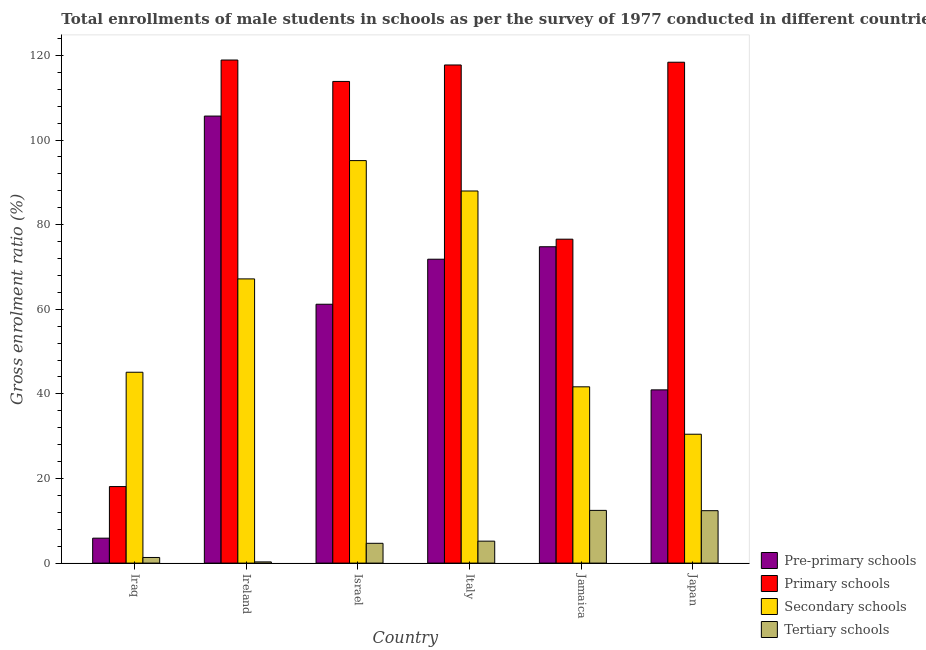How many different coloured bars are there?
Provide a succinct answer. 4. How many groups of bars are there?
Provide a short and direct response. 6. Are the number of bars per tick equal to the number of legend labels?
Ensure brevity in your answer.  Yes. Are the number of bars on each tick of the X-axis equal?
Your answer should be very brief. Yes. In how many cases, is the number of bars for a given country not equal to the number of legend labels?
Keep it short and to the point. 0. What is the gross enrolment ratio(male) in primary schools in Italy?
Your response must be concise. 117.75. Across all countries, what is the maximum gross enrolment ratio(male) in primary schools?
Ensure brevity in your answer.  118.92. Across all countries, what is the minimum gross enrolment ratio(male) in secondary schools?
Your response must be concise. 30.46. In which country was the gross enrolment ratio(male) in pre-primary schools maximum?
Give a very brief answer. Ireland. In which country was the gross enrolment ratio(male) in secondary schools minimum?
Keep it short and to the point. Japan. What is the total gross enrolment ratio(male) in secondary schools in the graph?
Your answer should be very brief. 367.54. What is the difference between the gross enrolment ratio(male) in primary schools in Israel and that in Italy?
Keep it short and to the point. -3.89. What is the difference between the gross enrolment ratio(male) in tertiary schools in Japan and the gross enrolment ratio(male) in primary schools in Iraq?
Ensure brevity in your answer.  -5.7. What is the average gross enrolment ratio(male) in secondary schools per country?
Offer a very short reply. 61.26. What is the difference between the gross enrolment ratio(male) in pre-primary schools and gross enrolment ratio(male) in primary schools in Iraq?
Your answer should be compact. -12.2. In how many countries, is the gross enrolment ratio(male) in secondary schools greater than 100 %?
Your answer should be compact. 0. What is the ratio of the gross enrolment ratio(male) in tertiary schools in Israel to that in Italy?
Give a very brief answer. 0.9. Is the gross enrolment ratio(male) in primary schools in Iraq less than that in Italy?
Ensure brevity in your answer.  Yes. What is the difference between the highest and the second highest gross enrolment ratio(male) in secondary schools?
Give a very brief answer. 7.18. What is the difference between the highest and the lowest gross enrolment ratio(male) in secondary schools?
Provide a succinct answer. 64.68. What does the 3rd bar from the left in Ireland represents?
Keep it short and to the point. Secondary schools. What does the 4th bar from the right in Italy represents?
Make the answer very short. Pre-primary schools. Is it the case that in every country, the sum of the gross enrolment ratio(male) in pre-primary schools and gross enrolment ratio(male) in primary schools is greater than the gross enrolment ratio(male) in secondary schools?
Provide a succinct answer. No. Are the values on the major ticks of Y-axis written in scientific E-notation?
Give a very brief answer. No. Does the graph contain any zero values?
Offer a terse response. No. Does the graph contain grids?
Your answer should be compact. No. How are the legend labels stacked?
Offer a terse response. Vertical. What is the title of the graph?
Your response must be concise. Total enrollments of male students in schools as per the survey of 1977 conducted in different countries. What is the label or title of the X-axis?
Provide a succinct answer. Country. What is the label or title of the Y-axis?
Offer a terse response. Gross enrolment ratio (%). What is the Gross enrolment ratio (%) in Pre-primary schools in Iraq?
Your response must be concise. 5.89. What is the Gross enrolment ratio (%) in Primary schools in Iraq?
Provide a short and direct response. 18.09. What is the Gross enrolment ratio (%) of Secondary schools in Iraq?
Make the answer very short. 45.11. What is the Gross enrolment ratio (%) of Tertiary schools in Iraq?
Your answer should be very brief. 1.33. What is the Gross enrolment ratio (%) of Pre-primary schools in Ireland?
Your answer should be compact. 105.67. What is the Gross enrolment ratio (%) of Primary schools in Ireland?
Ensure brevity in your answer.  118.92. What is the Gross enrolment ratio (%) of Secondary schools in Ireland?
Your response must be concise. 67.18. What is the Gross enrolment ratio (%) in Tertiary schools in Ireland?
Ensure brevity in your answer.  0.28. What is the Gross enrolment ratio (%) in Pre-primary schools in Israel?
Make the answer very short. 61.19. What is the Gross enrolment ratio (%) of Primary schools in Israel?
Your response must be concise. 113.86. What is the Gross enrolment ratio (%) of Secondary schools in Israel?
Provide a short and direct response. 95.14. What is the Gross enrolment ratio (%) in Tertiary schools in Israel?
Offer a terse response. 4.68. What is the Gross enrolment ratio (%) in Pre-primary schools in Italy?
Keep it short and to the point. 71.83. What is the Gross enrolment ratio (%) of Primary schools in Italy?
Make the answer very short. 117.75. What is the Gross enrolment ratio (%) in Secondary schools in Italy?
Keep it short and to the point. 87.96. What is the Gross enrolment ratio (%) in Tertiary schools in Italy?
Make the answer very short. 5.19. What is the Gross enrolment ratio (%) of Pre-primary schools in Jamaica?
Your response must be concise. 74.78. What is the Gross enrolment ratio (%) of Primary schools in Jamaica?
Make the answer very short. 76.57. What is the Gross enrolment ratio (%) of Secondary schools in Jamaica?
Give a very brief answer. 41.67. What is the Gross enrolment ratio (%) of Tertiary schools in Jamaica?
Your answer should be very brief. 12.46. What is the Gross enrolment ratio (%) in Pre-primary schools in Japan?
Your answer should be compact. 40.95. What is the Gross enrolment ratio (%) in Primary schools in Japan?
Keep it short and to the point. 118.4. What is the Gross enrolment ratio (%) in Secondary schools in Japan?
Provide a short and direct response. 30.46. What is the Gross enrolment ratio (%) in Tertiary schools in Japan?
Provide a succinct answer. 12.39. Across all countries, what is the maximum Gross enrolment ratio (%) of Pre-primary schools?
Your response must be concise. 105.67. Across all countries, what is the maximum Gross enrolment ratio (%) in Primary schools?
Provide a succinct answer. 118.92. Across all countries, what is the maximum Gross enrolment ratio (%) of Secondary schools?
Offer a terse response. 95.14. Across all countries, what is the maximum Gross enrolment ratio (%) in Tertiary schools?
Make the answer very short. 12.46. Across all countries, what is the minimum Gross enrolment ratio (%) in Pre-primary schools?
Your answer should be very brief. 5.89. Across all countries, what is the minimum Gross enrolment ratio (%) of Primary schools?
Keep it short and to the point. 18.09. Across all countries, what is the minimum Gross enrolment ratio (%) of Secondary schools?
Give a very brief answer. 30.46. Across all countries, what is the minimum Gross enrolment ratio (%) of Tertiary schools?
Offer a terse response. 0.28. What is the total Gross enrolment ratio (%) in Pre-primary schools in the graph?
Ensure brevity in your answer.  360.31. What is the total Gross enrolment ratio (%) in Primary schools in the graph?
Offer a very short reply. 563.58. What is the total Gross enrolment ratio (%) in Secondary schools in the graph?
Provide a succinct answer. 367.54. What is the total Gross enrolment ratio (%) in Tertiary schools in the graph?
Give a very brief answer. 36.33. What is the difference between the Gross enrolment ratio (%) in Pre-primary schools in Iraq and that in Ireland?
Your response must be concise. -99.78. What is the difference between the Gross enrolment ratio (%) of Primary schools in Iraq and that in Ireland?
Your response must be concise. -100.83. What is the difference between the Gross enrolment ratio (%) in Secondary schools in Iraq and that in Ireland?
Offer a very short reply. -22.07. What is the difference between the Gross enrolment ratio (%) of Tertiary schools in Iraq and that in Ireland?
Give a very brief answer. 1.05. What is the difference between the Gross enrolment ratio (%) in Pre-primary schools in Iraq and that in Israel?
Make the answer very short. -55.29. What is the difference between the Gross enrolment ratio (%) in Primary schools in Iraq and that in Israel?
Ensure brevity in your answer.  -95.77. What is the difference between the Gross enrolment ratio (%) in Secondary schools in Iraq and that in Israel?
Provide a succinct answer. -50.03. What is the difference between the Gross enrolment ratio (%) in Tertiary schools in Iraq and that in Israel?
Your answer should be very brief. -3.35. What is the difference between the Gross enrolment ratio (%) of Pre-primary schools in Iraq and that in Italy?
Make the answer very short. -65.94. What is the difference between the Gross enrolment ratio (%) of Primary schools in Iraq and that in Italy?
Your answer should be very brief. -99.66. What is the difference between the Gross enrolment ratio (%) of Secondary schools in Iraq and that in Italy?
Make the answer very short. -42.85. What is the difference between the Gross enrolment ratio (%) in Tertiary schools in Iraq and that in Italy?
Offer a terse response. -3.86. What is the difference between the Gross enrolment ratio (%) of Pre-primary schools in Iraq and that in Jamaica?
Provide a short and direct response. -68.89. What is the difference between the Gross enrolment ratio (%) of Primary schools in Iraq and that in Jamaica?
Your response must be concise. -58.48. What is the difference between the Gross enrolment ratio (%) of Secondary schools in Iraq and that in Jamaica?
Your answer should be very brief. 3.44. What is the difference between the Gross enrolment ratio (%) in Tertiary schools in Iraq and that in Jamaica?
Your response must be concise. -11.13. What is the difference between the Gross enrolment ratio (%) in Pre-primary schools in Iraq and that in Japan?
Provide a short and direct response. -35.05. What is the difference between the Gross enrolment ratio (%) of Primary schools in Iraq and that in Japan?
Keep it short and to the point. -100.31. What is the difference between the Gross enrolment ratio (%) in Secondary schools in Iraq and that in Japan?
Offer a terse response. 14.65. What is the difference between the Gross enrolment ratio (%) of Tertiary schools in Iraq and that in Japan?
Keep it short and to the point. -11.06. What is the difference between the Gross enrolment ratio (%) in Pre-primary schools in Ireland and that in Israel?
Your answer should be compact. 44.48. What is the difference between the Gross enrolment ratio (%) in Primary schools in Ireland and that in Israel?
Your answer should be very brief. 5.06. What is the difference between the Gross enrolment ratio (%) of Secondary schools in Ireland and that in Israel?
Offer a terse response. -27.96. What is the difference between the Gross enrolment ratio (%) in Tertiary schools in Ireland and that in Israel?
Keep it short and to the point. -4.39. What is the difference between the Gross enrolment ratio (%) in Pre-primary schools in Ireland and that in Italy?
Your answer should be very brief. 33.84. What is the difference between the Gross enrolment ratio (%) in Primary schools in Ireland and that in Italy?
Your response must be concise. 1.17. What is the difference between the Gross enrolment ratio (%) in Secondary schools in Ireland and that in Italy?
Your answer should be very brief. -20.78. What is the difference between the Gross enrolment ratio (%) in Tertiary schools in Ireland and that in Italy?
Offer a terse response. -4.9. What is the difference between the Gross enrolment ratio (%) of Pre-primary schools in Ireland and that in Jamaica?
Offer a terse response. 30.89. What is the difference between the Gross enrolment ratio (%) in Primary schools in Ireland and that in Jamaica?
Provide a short and direct response. 42.35. What is the difference between the Gross enrolment ratio (%) in Secondary schools in Ireland and that in Jamaica?
Your response must be concise. 25.51. What is the difference between the Gross enrolment ratio (%) in Tertiary schools in Ireland and that in Jamaica?
Offer a terse response. -12.18. What is the difference between the Gross enrolment ratio (%) of Pre-primary schools in Ireland and that in Japan?
Offer a terse response. 64.72. What is the difference between the Gross enrolment ratio (%) in Primary schools in Ireland and that in Japan?
Ensure brevity in your answer.  0.52. What is the difference between the Gross enrolment ratio (%) of Secondary schools in Ireland and that in Japan?
Give a very brief answer. 36.71. What is the difference between the Gross enrolment ratio (%) of Tertiary schools in Ireland and that in Japan?
Your response must be concise. -12.11. What is the difference between the Gross enrolment ratio (%) in Pre-primary schools in Israel and that in Italy?
Keep it short and to the point. -10.65. What is the difference between the Gross enrolment ratio (%) in Primary schools in Israel and that in Italy?
Offer a very short reply. -3.89. What is the difference between the Gross enrolment ratio (%) in Secondary schools in Israel and that in Italy?
Offer a terse response. 7.18. What is the difference between the Gross enrolment ratio (%) in Tertiary schools in Israel and that in Italy?
Provide a succinct answer. -0.51. What is the difference between the Gross enrolment ratio (%) of Pre-primary schools in Israel and that in Jamaica?
Offer a very short reply. -13.59. What is the difference between the Gross enrolment ratio (%) in Primary schools in Israel and that in Jamaica?
Keep it short and to the point. 37.29. What is the difference between the Gross enrolment ratio (%) in Secondary schools in Israel and that in Jamaica?
Offer a terse response. 53.47. What is the difference between the Gross enrolment ratio (%) of Tertiary schools in Israel and that in Jamaica?
Offer a terse response. -7.78. What is the difference between the Gross enrolment ratio (%) in Pre-primary schools in Israel and that in Japan?
Give a very brief answer. 20.24. What is the difference between the Gross enrolment ratio (%) in Primary schools in Israel and that in Japan?
Your answer should be compact. -4.54. What is the difference between the Gross enrolment ratio (%) in Secondary schools in Israel and that in Japan?
Ensure brevity in your answer.  64.68. What is the difference between the Gross enrolment ratio (%) of Tertiary schools in Israel and that in Japan?
Provide a short and direct response. -7.71. What is the difference between the Gross enrolment ratio (%) of Pre-primary schools in Italy and that in Jamaica?
Your answer should be compact. -2.95. What is the difference between the Gross enrolment ratio (%) of Primary schools in Italy and that in Jamaica?
Your answer should be very brief. 41.18. What is the difference between the Gross enrolment ratio (%) in Secondary schools in Italy and that in Jamaica?
Offer a terse response. 46.29. What is the difference between the Gross enrolment ratio (%) in Tertiary schools in Italy and that in Jamaica?
Your answer should be very brief. -7.27. What is the difference between the Gross enrolment ratio (%) of Pre-primary schools in Italy and that in Japan?
Your answer should be very brief. 30.89. What is the difference between the Gross enrolment ratio (%) in Primary schools in Italy and that in Japan?
Your answer should be very brief. -0.65. What is the difference between the Gross enrolment ratio (%) of Secondary schools in Italy and that in Japan?
Keep it short and to the point. 57.5. What is the difference between the Gross enrolment ratio (%) of Tertiary schools in Italy and that in Japan?
Offer a very short reply. -7.2. What is the difference between the Gross enrolment ratio (%) of Pre-primary schools in Jamaica and that in Japan?
Offer a very short reply. 33.83. What is the difference between the Gross enrolment ratio (%) of Primary schools in Jamaica and that in Japan?
Your answer should be very brief. -41.83. What is the difference between the Gross enrolment ratio (%) in Secondary schools in Jamaica and that in Japan?
Ensure brevity in your answer.  11.21. What is the difference between the Gross enrolment ratio (%) in Tertiary schools in Jamaica and that in Japan?
Your answer should be compact. 0.07. What is the difference between the Gross enrolment ratio (%) of Pre-primary schools in Iraq and the Gross enrolment ratio (%) of Primary schools in Ireland?
Give a very brief answer. -113.02. What is the difference between the Gross enrolment ratio (%) in Pre-primary schools in Iraq and the Gross enrolment ratio (%) in Secondary schools in Ireland?
Your response must be concise. -61.29. What is the difference between the Gross enrolment ratio (%) in Pre-primary schools in Iraq and the Gross enrolment ratio (%) in Tertiary schools in Ireland?
Offer a very short reply. 5.61. What is the difference between the Gross enrolment ratio (%) in Primary schools in Iraq and the Gross enrolment ratio (%) in Secondary schools in Ireland?
Ensure brevity in your answer.  -49.09. What is the difference between the Gross enrolment ratio (%) in Primary schools in Iraq and the Gross enrolment ratio (%) in Tertiary schools in Ireland?
Offer a very short reply. 17.81. What is the difference between the Gross enrolment ratio (%) in Secondary schools in Iraq and the Gross enrolment ratio (%) in Tertiary schools in Ireland?
Provide a succinct answer. 44.83. What is the difference between the Gross enrolment ratio (%) of Pre-primary schools in Iraq and the Gross enrolment ratio (%) of Primary schools in Israel?
Your answer should be very brief. -107.96. What is the difference between the Gross enrolment ratio (%) in Pre-primary schools in Iraq and the Gross enrolment ratio (%) in Secondary schools in Israel?
Keep it short and to the point. -89.25. What is the difference between the Gross enrolment ratio (%) of Pre-primary schools in Iraq and the Gross enrolment ratio (%) of Tertiary schools in Israel?
Make the answer very short. 1.22. What is the difference between the Gross enrolment ratio (%) of Primary schools in Iraq and the Gross enrolment ratio (%) of Secondary schools in Israel?
Offer a very short reply. -77.05. What is the difference between the Gross enrolment ratio (%) in Primary schools in Iraq and the Gross enrolment ratio (%) in Tertiary schools in Israel?
Ensure brevity in your answer.  13.41. What is the difference between the Gross enrolment ratio (%) of Secondary schools in Iraq and the Gross enrolment ratio (%) of Tertiary schools in Israel?
Your answer should be very brief. 40.44. What is the difference between the Gross enrolment ratio (%) in Pre-primary schools in Iraq and the Gross enrolment ratio (%) in Primary schools in Italy?
Give a very brief answer. -111.85. What is the difference between the Gross enrolment ratio (%) of Pre-primary schools in Iraq and the Gross enrolment ratio (%) of Secondary schools in Italy?
Your response must be concise. -82.07. What is the difference between the Gross enrolment ratio (%) in Pre-primary schools in Iraq and the Gross enrolment ratio (%) in Tertiary schools in Italy?
Offer a terse response. 0.71. What is the difference between the Gross enrolment ratio (%) of Primary schools in Iraq and the Gross enrolment ratio (%) of Secondary schools in Italy?
Make the answer very short. -69.87. What is the difference between the Gross enrolment ratio (%) of Primary schools in Iraq and the Gross enrolment ratio (%) of Tertiary schools in Italy?
Provide a short and direct response. 12.9. What is the difference between the Gross enrolment ratio (%) of Secondary schools in Iraq and the Gross enrolment ratio (%) of Tertiary schools in Italy?
Your response must be concise. 39.93. What is the difference between the Gross enrolment ratio (%) of Pre-primary schools in Iraq and the Gross enrolment ratio (%) of Primary schools in Jamaica?
Your response must be concise. -70.67. What is the difference between the Gross enrolment ratio (%) of Pre-primary schools in Iraq and the Gross enrolment ratio (%) of Secondary schools in Jamaica?
Your response must be concise. -35.78. What is the difference between the Gross enrolment ratio (%) in Pre-primary schools in Iraq and the Gross enrolment ratio (%) in Tertiary schools in Jamaica?
Ensure brevity in your answer.  -6.57. What is the difference between the Gross enrolment ratio (%) in Primary schools in Iraq and the Gross enrolment ratio (%) in Secondary schools in Jamaica?
Provide a short and direct response. -23.58. What is the difference between the Gross enrolment ratio (%) of Primary schools in Iraq and the Gross enrolment ratio (%) of Tertiary schools in Jamaica?
Ensure brevity in your answer.  5.63. What is the difference between the Gross enrolment ratio (%) of Secondary schools in Iraq and the Gross enrolment ratio (%) of Tertiary schools in Jamaica?
Give a very brief answer. 32.65. What is the difference between the Gross enrolment ratio (%) of Pre-primary schools in Iraq and the Gross enrolment ratio (%) of Primary schools in Japan?
Provide a succinct answer. -112.51. What is the difference between the Gross enrolment ratio (%) of Pre-primary schools in Iraq and the Gross enrolment ratio (%) of Secondary schools in Japan?
Ensure brevity in your answer.  -24.57. What is the difference between the Gross enrolment ratio (%) of Pre-primary schools in Iraq and the Gross enrolment ratio (%) of Tertiary schools in Japan?
Your response must be concise. -6.5. What is the difference between the Gross enrolment ratio (%) of Primary schools in Iraq and the Gross enrolment ratio (%) of Secondary schools in Japan?
Provide a short and direct response. -12.37. What is the difference between the Gross enrolment ratio (%) in Secondary schools in Iraq and the Gross enrolment ratio (%) in Tertiary schools in Japan?
Provide a succinct answer. 32.72. What is the difference between the Gross enrolment ratio (%) in Pre-primary schools in Ireland and the Gross enrolment ratio (%) in Primary schools in Israel?
Offer a terse response. -8.19. What is the difference between the Gross enrolment ratio (%) in Pre-primary schools in Ireland and the Gross enrolment ratio (%) in Secondary schools in Israel?
Give a very brief answer. 10.53. What is the difference between the Gross enrolment ratio (%) in Pre-primary schools in Ireland and the Gross enrolment ratio (%) in Tertiary schools in Israel?
Ensure brevity in your answer.  100.99. What is the difference between the Gross enrolment ratio (%) of Primary schools in Ireland and the Gross enrolment ratio (%) of Secondary schools in Israel?
Give a very brief answer. 23.77. What is the difference between the Gross enrolment ratio (%) of Primary schools in Ireland and the Gross enrolment ratio (%) of Tertiary schools in Israel?
Give a very brief answer. 114.24. What is the difference between the Gross enrolment ratio (%) in Secondary schools in Ireland and the Gross enrolment ratio (%) in Tertiary schools in Israel?
Offer a very short reply. 62.5. What is the difference between the Gross enrolment ratio (%) of Pre-primary schools in Ireland and the Gross enrolment ratio (%) of Primary schools in Italy?
Your answer should be compact. -12.08. What is the difference between the Gross enrolment ratio (%) in Pre-primary schools in Ireland and the Gross enrolment ratio (%) in Secondary schools in Italy?
Give a very brief answer. 17.71. What is the difference between the Gross enrolment ratio (%) of Pre-primary schools in Ireland and the Gross enrolment ratio (%) of Tertiary schools in Italy?
Your response must be concise. 100.48. What is the difference between the Gross enrolment ratio (%) of Primary schools in Ireland and the Gross enrolment ratio (%) of Secondary schools in Italy?
Give a very brief answer. 30.96. What is the difference between the Gross enrolment ratio (%) in Primary schools in Ireland and the Gross enrolment ratio (%) in Tertiary schools in Italy?
Keep it short and to the point. 113.73. What is the difference between the Gross enrolment ratio (%) in Secondary schools in Ireland and the Gross enrolment ratio (%) in Tertiary schools in Italy?
Ensure brevity in your answer.  61.99. What is the difference between the Gross enrolment ratio (%) in Pre-primary schools in Ireland and the Gross enrolment ratio (%) in Primary schools in Jamaica?
Make the answer very short. 29.1. What is the difference between the Gross enrolment ratio (%) in Pre-primary schools in Ireland and the Gross enrolment ratio (%) in Secondary schools in Jamaica?
Offer a terse response. 64. What is the difference between the Gross enrolment ratio (%) in Pre-primary schools in Ireland and the Gross enrolment ratio (%) in Tertiary schools in Jamaica?
Make the answer very short. 93.21. What is the difference between the Gross enrolment ratio (%) of Primary schools in Ireland and the Gross enrolment ratio (%) of Secondary schools in Jamaica?
Offer a terse response. 77.25. What is the difference between the Gross enrolment ratio (%) in Primary schools in Ireland and the Gross enrolment ratio (%) in Tertiary schools in Jamaica?
Provide a short and direct response. 106.46. What is the difference between the Gross enrolment ratio (%) of Secondary schools in Ireland and the Gross enrolment ratio (%) of Tertiary schools in Jamaica?
Your answer should be very brief. 54.72. What is the difference between the Gross enrolment ratio (%) in Pre-primary schools in Ireland and the Gross enrolment ratio (%) in Primary schools in Japan?
Your response must be concise. -12.73. What is the difference between the Gross enrolment ratio (%) of Pre-primary schools in Ireland and the Gross enrolment ratio (%) of Secondary schools in Japan?
Offer a very short reply. 75.21. What is the difference between the Gross enrolment ratio (%) of Pre-primary schools in Ireland and the Gross enrolment ratio (%) of Tertiary schools in Japan?
Ensure brevity in your answer.  93.28. What is the difference between the Gross enrolment ratio (%) in Primary schools in Ireland and the Gross enrolment ratio (%) in Secondary schools in Japan?
Offer a very short reply. 88.45. What is the difference between the Gross enrolment ratio (%) of Primary schools in Ireland and the Gross enrolment ratio (%) of Tertiary schools in Japan?
Give a very brief answer. 106.53. What is the difference between the Gross enrolment ratio (%) in Secondary schools in Ireland and the Gross enrolment ratio (%) in Tertiary schools in Japan?
Your response must be concise. 54.79. What is the difference between the Gross enrolment ratio (%) of Pre-primary schools in Israel and the Gross enrolment ratio (%) of Primary schools in Italy?
Ensure brevity in your answer.  -56.56. What is the difference between the Gross enrolment ratio (%) in Pre-primary schools in Israel and the Gross enrolment ratio (%) in Secondary schools in Italy?
Your answer should be compact. -26.77. What is the difference between the Gross enrolment ratio (%) of Primary schools in Israel and the Gross enrolment ratio (%) of Secondary schools in Italy?
Keep it short and to the point. 25.9. What is the difference between the Gross enrolment ratio (%) in Primary schools in Israel and the Gross enrolment ratio (%) in Tertiary schools in Italy?
Provide a succinct answer. 108.67. What is the difference between the Gross enrolment ratio (%) in Secondary schools in Israel and the Gross enrolment ratio (%) in Tertiary schools in Italy?
Provide a short and direct response. 89.96. What is the difference between the Gross enrolment ratio (%) of Pre-primary schools in Israel and the Gross enrolment ratio (%) of Primary schools in Jamaica?
Your answer should be very brief. -15.38. What is the difference between the Gross enrolment ratio (%) of Pre-primary schools in Israel and the Gross enrolment ratio (%) of Secondary schools in Jamaica?
Provide a succinct answer. 19.52. What is the difference between the Gross enrolment ratio (%) in Pre-primary schools in Israel and the Gross enrolment ratio (%) in Tertiary schools in Jamaica?
Your answer should be very brief. 48.73. What is the difference between the Gross enrolment ratio (%) in Primary schools in Israel and the Gross enrolment ratio (%) in Secondary schools in Jamaica?
Make the answer very short. 72.19. What is the difference between the Gross enrolment ratio (%) of Primary schools in Israel and the Gross enrolment ratio (%) of Tertiary schools in Jamaica?
Your answer should be very brief. 101.4. What is the difference between the Gross enrolment ratio (%) of Secondary schools in Israel and the Gross enrolment ratio (%) of Tertiary schools in Jamaica?
Provide a short and direct response. 82.68. What is the difference between the Gross enrolment ratio (%) of Pre-primary schools in Israel and the Gross enrolment ratio (%) of Primary schools in Japan?
Offer a very short reply. -57.21. What is the difference between the Gross enrolment ratio (%) of Pre-primary schools in Israel and the Gross enrolment ratio (%) of Secondary schools in Japan?
Ensure brevity in your answer.  30.72. What is the difference between the Gross enrolment ratio (%) in Pre-primary schools in Israel and the Gross enrolment ratio (%) in Tertiary schools in Japan?
Give a very brief answer. 48.8. What is the difference between the Gross enrolment ratio (%) of Primary schools in Israel and the Gross enrolment ratio (%) of Secondary schools in Japan?
Offer a very short reply. 83.39. What is the difference between the Gross enrolment ratio (%) of Primary schools in Israel and the Gross enrolment ratio (%) of Tertiary schools in Japan?
Your answer should be very brief. 101.47. What is the difference between the Gross enrolment ratio (%) of Secondary schools in Israel and the Gross enrolment ratio (%) of Tertiary schools in Japan?
Provide a short and direct response. 82.75. What is the difference between the Gross enrolment ratio (%) in Pre-primary schools in Italy and the Gross enrolment ratio (%) in Primary schools in Jamaica?
Provide a short and direct response. -4.73. What is the difference between the Gross enrolment ratio (%) of Pre-primary schools in Italy and the Gross enrolment ratio (%) of Secondary schools in Jamaica?
Offer a terse response. 30.16. What is the difference between the Gross enrolment ratio (%) in Pre-primary schools in Italy and the Gross enrolment ratio (%) in Tertiary schools in Jamaica?
Your response must be concise. 59.37. What is the difference between the Gross enrolment ratio (%) in Primary schools in Italy and the Gross enrolment ratio (%) in Secondary schools in Jamaica?
Ensure brevity in your answer.  76.08. What is the difference between the Gross enrolment ratio (%) of Primary schools in Italy and the Gross enrolment ratio (%) of Tertiary schools in Jamaica?
Give a very brief answer. 105.29. What is the difference between the Gross enrolment ratio (%) of Secondary schools in Italy and the Gross enrolment ratio (%) of Tertiary schools in Jamaica?
Your answer should be compact. 75.5. What is the difference between the Gross enrolment ratio (%) in Pre-primary schools in Italy and the Gross enrolment ratio (%) in Primary schools in Japan?
Make the answer very short. -46.56. What is the difference between the Gross enrolment ratio (%) of Pre-primary schools in Italy and the Gross enrolment ratio (%) of Secondary schools in Japan?
Ensure brevity in your answer.  41.37. What is the difference between the Gross enrolment ratio (%) of Pre-primary schools in Italy and the Gross enrolment ratio (%) of Tertiary schools in Japan?
Your answer should be compact. 59.44. What is the difference between the Gross enrolment ratio (%) in Primary schools in Italy and the Gross enrolment ratio (%) in Secondary schools in Japan?
Provide a succinct answer. 87.28. What is the difference between the Gross enrolment ratio (%) of Primary schools in Italy and the Gross enrolment ratio (%) of Tertiary schools in Japan?
Ensure brevity in your answer.  105.36. What is the difference between the Gross enrolment ratio (%) of Secondary schools in Italy and the Gross enrolment ratio (%) of Tertiary schools in Japan?
Keep it short and to the point. 75.57. What is the difference between the Gross enrolment ratio (%) of Pre-primary schools in Jamaica and the Gross enrolment ratio (%) of Primary schools in Japan?
Provide a succinct answer. -43.62. What is the difference between the Gross enrolment ratio (%) in Pre-primary schools in Jamaica and the Gross enrolment ratio (%) in Secondary schools in Japan?
Provide a succinct answer. 44.31. What is the difference between the Gross enrolment ratio (%) in Pre-primary schools in Jamaica and the Gross enrolment ratio (%) in Tertiary schools in Japan?
Provide a short and direct response. 62.39. What is the difference between the Gross enrolment ratio (%) in Primary schools in Jamaica and the Gross enrolment ratio (%) in Secondary schools in Japan?
Provide a short and direct response. 46.1. What is the difference between the Gross enrolment ratio (%) in Primary schools in Jamaica and the Gross enrolment ratio (%) in Tertiary schools in Japan?
Your answer should be compact. 64.18. What is the difference between the Gross enrolment ratio (%) of Secondary schools in Jamaica and the Gross enrolment ratio (%) of Tertiary schools in Japan?
Ensure brevity in your answer.  29.28. What is the average Gross enrolment ratio (%) in Pre-primary schools per country?
Offer a terse response. 60.05. What is the average Gross enrolment ratio (%) in Primary schools per country?
Your answer should be compact. 93.93. What is the average Gross enrolment ratio (%) of Secondary schools per country?
Your answer should be very brief. 61.26. What is the average Gross enrolment ratio (%) of Tertiary schools per country?
Provide a short and direct response. 6.06. What is the difference between the Gross enrolment ratio (%) of Pre-primary schools and Gross enrolment ratio (%) of Primary schools in Iraq?
Keep it short and to the point. -12.2. What is the difference between the Gross enrolment ratio (%) in Pre-primary schools and Gross enrolment ratio (%) in Secondary schools in Iraq?
Offer a terse response. -39.22. What is the difference between the Gross enrolment ratio (%) of Pre-primary schools and Gross enrolment ratio (%) of Tertiary schools in Iraq?
Give a very brief answer. 4.56. What is the difference between the Gross enrolment ratio (%) of Primary schools and Gross enrolment ratio (%) of Secondary schools in Iraq?
Your response must be concise. -27.02. What is the difference between the Gross enrolment ratio (%) in Primary schools and Gross enrolment ratio (%) in Tertiary schools in Iraq?
Your answer should be compact. 16.76. What is the difference between the Gross enrolment ratio (%) in Secondary schools and Gross enrolment ratio (%) in Tertiary schools in Iraq?
Your answer should be compact. 43.78. What is the difference between the Gross enrolment ratio (%) of Pre-primary schools and Gross enrolment ratio (%) of Primary schools in Ireland?
Your answer should be very brief. -13.25. What is the difference between the Gross enrolment ratio (%) in Pre-primary schools and Gross enrolment ratio (%) in Secondary schools in Ireland?
Provide a succinct answer. 38.49. What is the difference between the Gross enrolment ratio (%) in Pre-primary schools and Gross enrolment ratio (%) in Tertiary schools in Ireland?
Give a very brief answer. 105.39. What is the difference between the Gross enrolment ratio (%) of Primary schools and Gross enrolment ratio (%) of Secondary schools in Ireland?
Your response must be concise. 51.74. What is the difference between the Gross enrolment ratio (%) of Primary schools and Gross enrolment ratio (%) of Tertiary schools in Ireland?
Provide a short and direct response. 118.63. What is the difference between the Gross enrolment ratio (%) in Secondary schools and Gross enrolment ratio (%) in Tertiary schools in Ireland?
Ensure brevity in your answer.  66.89. What is the difference between the Gross enrolment ratio (%) of Pre-primary schools and Gross enrolment ratio (%) of Primary schools in Israel?
Give a very brief answer. -52.67. What is the difference between the Gross enrolment ratio (%) of Pre-primary schools and Gross enrolment ratio (%) of Secondary schools in Israel?
Provide a short and direct response. -33.96. What is the difference between the Gross enrolment ratio (%) of Pre-primary schools and Gross enrolment ratio (%) of Tertiary schools in Israel?
Your response must be concise. 56.51. What is the difference between the Gross enrolment ratio (%) in Primary schools and Gross enrolment ratio (%) in Secondary schools in Israel?
Ensure brevity in your answer.  18.71. What is the difference between the Gross enrolment ratio (%) of Primary schools and Gross enrolment ratio (%) of Tertiary schools in Israel?
Offer a very short reply. 109.18. What is the difference between the Gross enrolment ratio (%) of Secondary schools and Gross enrolment ratio (%) of Tertiary schools in Israel?
Make the answer very short. 90.47. What is the difference between the Gross enrolment ratio (%) in Pre-primary schools and Gross enrolment ratio (%) in Primary schools in Italy?
Make the answer very short. -45.91. What is the difference between the Gross enrolment ratio (%) of Pre-primary schools and Gross enrolment ratio (%) of Secondary schools in Italy?
Your answer should be very brief. -16.13. What is the difference between the Gross enrolment ratio (%) of Pre-primary schools and Gross enrolment ratio (%) of Tertiary schools in Italy?
Your response must be concise. 66.65. What is the difference between the Gross enrolment ratio (%) in Primary schools and Gross enrolment ratio (%) in Secondary schools in Italy?
Offer a terse response. 29.79. What is the difference between the Gross enrolment ratio (%) of Primary schools and Gross enrolment ratio (%) of Tertiary schools in Italy?
Offer a terse response. 112.56. What is the difference between the Gross enrolment ratio (%) in Secondary schools and Gross enrolment ratio (%) in Tertiary schools in Italy?
Give a very brief answer. 82.77. What is the difference between the Gross enrolment ratio (%) in Pre-primary schools and Gross enrolment ratio (%) in Primary schools in Jamaica?
Ensure brevity in your answer.  -1.79. What is the difference between the Gross enrolment ratio (%) in Pre-primary schools and Gross enrolment ratio (%) in Secondary schools in Jamaica?
Your response must be concise. 33.11. What is the difference between the Gross enrolment ratio (%) of Pre-primary schools and Gross enrolment ratio (%) of Tertiary schools in Jamaica?
Offer a terse response. 62.32. What is the difference between the Gross enrolment ratio (%) of Primary schools and Gross enrolment ratio (%) of Secondary schools in Jamaica?
Offer a terse response. 34.9. What is the difference between the Gross enrolment ratio (%) of Primary schools and Gross enrolment ratio (%) of Tertiary schools in Jamaica?
Offer a terse response. 64.11. What is the difference between the Gross enrolment ratio (%) in Secondary schools and Gross enrolment ratio (%) in Tertiary schools in Jamaica?
Offer a very short reply. 29.21. What is the difference between the Gross enrolment ratio (%) in Pre-primary schools and Gross enrolment ratio (%) in Primary schools in Japan?
Keep it short and to the point. -77.45. What is the difference between the Gross enrolment ratio (%) in Pre-primary schools and Gross enrolment ratio (%) in Secondary schools in Japan?
Your answer should be compact. 10.48. What is the difference between the Gross enrolment ratio (%) in Pre-primary schools and Gross enrolment ratio (%) in Tertiary schools in Japan?
Your answer should be compact. 28.56. What is the difference between the Gross enrolment ratio (%) in Primary schools and Gross enrolment ratio (%) in Secondary schools in Japan?
Your response must be concise. 87.93. What is the difference between the Gross enrolment ratio (%) of Primary schools and Gross enrolment ratio (%) of Tertiary schools in Japan?
Make the answer very short. 106.01. What is the difference between the Gross enrolment ratio (%) in Secondary schools and Gross enrolment ratio (%) in Tertiary schools in Japan?
Give a very brief answer. 18.07. What is the ratio of the Gross enrolment ratio (%) in Pre-primary schools in Iraq to that in Ireland?
Keep it short and to the point. 0.06. What is the ratio of the Gross enrolment ratio (%) of Primary schools in Iraq to that in Ireland?
Offer a very short reply. 0.15. What is the ratio of the Gross enrolment ratio (%) of Secondary schools in Iraq to that in Ireland?
Keep it short and to the point. 0.67. What is the ratio of the Gross enrolment ratio (%) of Tertiary schools in Iraq to that in Ireland?
Your answer should be compact. 4.67. What is the ratio of the Gross enrolment ratio (%) in Pre-primary schools in Iraq to that in Israel?
Make the answer very short. 0.1. What is the ratio of the Gross enrolment ratio (%) of Primary schools in Iraq to that in Israel?
Your answer should be very brief. 0.16. What is the ratio of the Gross enrolment ratio (%) of Secondary schools in Iraq to that in Israel?
Keep it short and to the point. 0.47. What is the ratio of the Gross enrolment ratio (%) in Tertiary schools in Iraq to that in Israel?
Ensure brevity in your answer.  0.28. What is the ratio of the Gross enrolment ratio (%) in Pre-primary schools in Iraq to that in Italy?
Offer a terse response. 0.08. What is the ratio of the Gross enrolment ratio (%) in Primary schools in Iraq to that in Italy?
Keep it short and to the point. 0.15. What is the ratio of the Gross enrolment ratio (%) in Secondary schools in Iraq to that in Italy?
Your answer should be compact. 0.51. What is the ratio of the Gross enrolment ratio (%) in Tertiary schools in Iraq to that in Italy?
Provide a short and direct response. 0.26. What is the ratio of the Gross enrolment ratio (%) of Pre-primary schools in Iraq to that in Jamaica?
Give a very brief answer. 0.08. What is the ratio of the Gross enrolment ratio (%) of Primary schools in Iraq to that in Jamaica?
Provide a succinct answer. 0.24. What is the ratio of the Gross enrolment ratio (%) of Secondary schools in Iraq to that in Jamaica?
Offer a very short reply. 1.08. What is the ratio of the Gross enrolment ratio (%) of Tertiary schools in Iraq to that in Jamaica?
Your response must be concise. 0.11. What is the ratio of the Gross enrolment ratio (%) of Pre-primary schools in Iraq to that in Japan?
Make the answer very short. 0.14. What is the ratio of the Gross enrolment ratio (%) in Primary schools in Iraq to that in Japan?
Your answer should be compact. 0.15. What is the ratio of the Gross enrolment ratio (%) in Secondary schools in Iraq to that in Japan?
Give a very brief answer. 1.48. What is the ratio of the Gross enrolment ratio (%) of Tertiary schools in Iraq to that in Japan?
Offer a terse response. 0.11. What is the ratio of the Gross enrolment ratio (%) of Pre-primary schools in Ireland to that in Israel?
Your answer should be compact. 1.73. What is the ratio of the Gross enrolment ratio (%) in Primary schools in Ireland to that in Israel?
Your answer should be very brief. 1.04. What is the ratio of the Gross enrolment ratio (%) in Secondary schools in Ireland to that in Israel?
Your answer should be compact. 0.71. What is the ratio of the Gross enrolment ratio (%) in Tertiary schools in Ireland to that in Israel?
Your response must be concise. 0.06. What is the ratio of the Gross enrolment ratio (%) of Pre-primary schools in Ireland to that in Italy?
Your answer should be very brief. 1.47. What is the ratio of the Gross enrolment ratio (%) in Primary schools in Ireland to that in Italy?
Make the answer very short. 1.01. What is the ratio of the Gross enrolment ratio (%) in Secondary schools in Ireland to that in Italy?
Offer a very short reply. 0.76. What is the ratio of the Gross enrolment ratio (%) of Tertiary schools in Ireland to that in Italy?
Make the answer very short. 0.05. What is the ratio of the Gross enrolment ratio (%) of Pre-primary schools in Ireland to that in Jamaica?
Provide a short and direct response. 1.41. What is the ratio of the Gross enrolment ratio (%) in Primary schools in Ireland to that in Jamaica?
Your answer should be very brief. 1.55. What is the ratio of the Gross enrolment ratio (%) in Secondary schools in Ireland to that in Jamaica?
Offer a terse response. 1.61. What is the ratio of the Gross enrolment ratio (%) in Tertiary schools in Ireland to that in Jamaica?
Your answer should be very brief. 0.02. What is the ratio of the Gross enrolment ratio (%) of Pre-primary schools in Ireland to that in Japan?
Offer a very short reply. 2.58. What is the ratio of the Gross enrolment ratio (%) of Primary schools in Ireland to that in Japan?
Your answer should be compact. 1. What is the ratio of the Gross enrolment ratio (%) in Secondary schools in Ireland to that in Japan?
Ensure brevity in your answer.  2.21. What is the ratio of the Gross enrolment ratio (%) in Tertiary schools in Ireland to that in Japan?
Your answer should be compact. 0.02. What is the ratio of the Gross enrolment ratio (%) of Pre-primary schools in Israel to that in Italy?
Your answer should be compact. 0.85. What is the ratio of the Gross enrolment ratio (%) of Primary schools in Israel to that in Italy?
Offer a terse response. 0.97. What is the ratio of the Gross enrolment ratio (%) in Secondary schools in Israel to that in Italy?
Offer a terse response. 1.08. What is the ratio of the Gross enrolment ratio (%) of Tertiary schools in Israel to that in Italy?
Provide a short and direct response. 0.9. What is the ratio of the Gross enrolment ratio (%) in Pre-primary schools in Israel to that in Jamaica?
Your response must be concise. 0.82. What is the ratio of the Gross enrolment ratio (%) of Primary schools in Israel to that in Jamaica?
Your response must be concise. 1.49. What is the ratio of the Gross enrolment ratio (%) of Secondary schools in Israel to that in Jamaica?
Your answer should be compact. 2.28. What is the ratio of the Gross enrolment ratio (%) of Tertiary schools in Israel to that in Jamaica?
Your answer should be very brief. 0.38. What is the ratio of the Gross enrolment ratio (%) of Pre-primary schools in Israel to that in Japan?
Provide a short and direct response. 1.49. What is the ratio of the Gross enrolment ratio (%) of Primary schools in Israel to that in Japan?
Offer a terse response. 0.96. What is the ratio of the Gross enrolment ratio (%) of Secondary schools in Israel to that in Japan?
Your answer should be very brief. 3.12. What is the ratio of the Gross enrolment ratio (%) of Tertiary schools in Israel to that in Japan?
Keep it short and to the point. 0.38. What is the ratio of the Gross enrolment ratio (%) of Pre-primary schools in Italy to that in Jamaica?
Your answer should be very brief. 0.96. What is the ratio of the Gross enrolment ratio (%) in Primary schools in Italy to that in Jamaica?
Offer a terse response. 1.54. What is the ratio of the Gross enrolment ratio (%) in Secondary schools in Italy to that in Jamaica?
Offer a terse response. 2.11. What is the ratio of the Gross enrolment ratio (%) of Tertiary schools in Italy to that in Jamaica?
Provide a short and direct response. 0.42. What is the ratio of the Gross enrolment ratio (%) in Pre-primary schools in Italy to that in Japan?
Provide a short and direct response. 1.75. What is the ratio of the Gross enrolment ratio (%) of Secondary schools in Italy to that in Japan?
Ensure brevity in your answer.  2.89. What is the ratio of the Gross enrolment ratio (%) in Tertiary schools in Italy to that in Japan?
Your answer should be very brief. 0.42. What is the ratio of the Gross enrolment ratio (%) of Pre-primary schools in Jamaica to that in Japan?
Provide a succinct answer. 1.83. What is the ratio of the Gross enrolment ratio (%) in Primary schools in Jamaica to that in Japan?
Provide a short and direct response. 0.65. What is the ratio of the Gross enrolment ratio (%) of Secondary schools in Jamaica to that in Japan?
Give a very brief answer. 1.37. What is the ratio of the Gross enrolment ratio (%) in Tertiary schools in Jamaica to that in Japan?
Ensure brevity in your answer.  1.01. What is the difference between the highest and the second highest Gross enrolment ratio (%) of Pre-primary schools?
Your answer should be compact. 30.89. What is the difference between the highest and the second highest Gross enrolment ratio (%) in Primary schools?
Offer a very short reply. 0.52. What is the difference between the highest and the second highest Gross enrolment ratio (%) of Secondary schools?
Keep it short and to the point. 7.18. What is the difference between the highest and the second highest Gross enrolment ratio (%) in Tertiary schools?
Your answer should be very brief. 0.07. What is the difference between the highest and the lowest Gross enrolment ratio (%) of Pre-primary schools?
Keep it short and to the point. 99.78. What is the difference between the highest and the lowest Gross enrolment ratio (%) in Primary schools?
Your response must be concise. 100.83. What is the difference between the highest and the lowest Gross enrolment ratio (%) of Secondary schools?
Provide a short and direct response. 64.68. What is the difference between the highest and the lowest Gross enrolment ratio (%) of Tertiary schools?
Your answer should be compact. 12.18. 